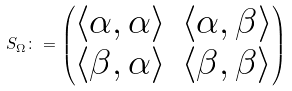Convert formula to latex. <formula><loc_0><loc_0><loc_500><loc_500>S _ { \Omega } \colon = \begin{pmatrix} \langle \alpha , \alpha \rangle & \langle \alpha , \beta \rangle \\ \langle \beta , \alpha \rangle & \langle \beta , \beta \rangle \end{pmatrix}</formula> 